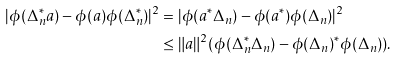<formula> <loc_0><loc_0><loc_500><loc_500>| \phi ( \Delta _ { n } ^ { * } a ) - \phi ( a ) \phi ( \Delta ^ { * } _ { n } ) | ^ { 2 } & = | \phi ( a ^ { * } \Delta _ { n } ) - \phi ( a ^ { * } ) \phi ( \Delta _ { n } ) | ^ { 2 } \\ & \leq \| a \| ^ { 2 } ( \phi ( \Delta _ { n } ^ { * } \Delta _ { n } ) - \phi ( \Delta _ { n } ) ^ { * } \phi ( \Delta _ { n } ) ) .</formula> 